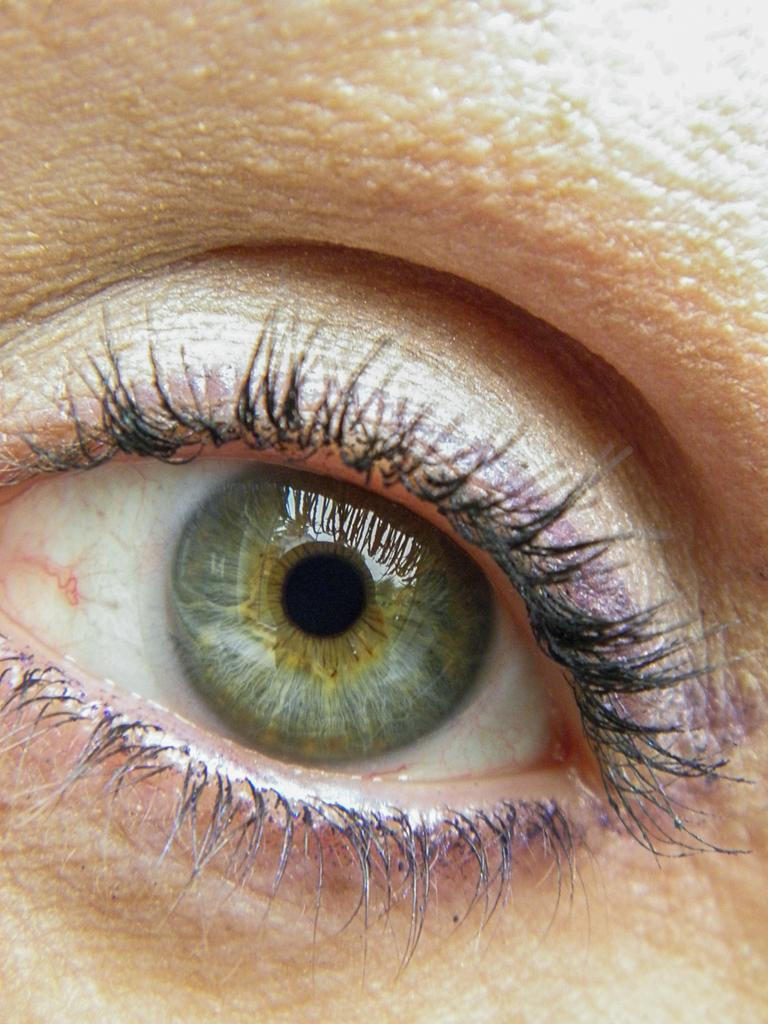What is the main subject of the image? The main subject of the image is a person's eye. Can you describe the eye in the image? The eye is in the center of the image. How many sisters does the person with the eye in the image have? There is no information about the person's family or siblings in the image, so we cannot determine the number of sisters they have. 